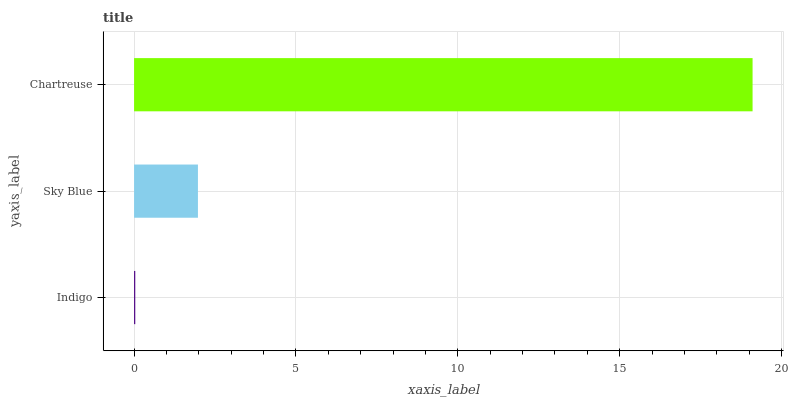Is Indigo the minimum?
Answer yes or no. Yes. Is Chartreuse the maximum?
Answer yes or no. Yes. Is Sky Blue the minimum?
Answer yes or no. No. Is Sky Blue the maximum?
Answer yes or no. No. Is Sky Blue greater than Indigo?
Answer yes or no. Yes. Is Indigo less than Sky Blue?
Answer yes or no. Yes. Is Indigo greater than Sky Blue?
Answer yes or no. No. Is Sky Blue less than Indigo?
Answer yes or no. No. Is Sky Blue the high median?
Answer yes or no. Yes. Is Sky Blue the low median?
Answer yes or no. Yes. Is Chartreuse the high median?
Answer yes or no. No. Is Chartreuse the low median?
Answer yes or no. No. 